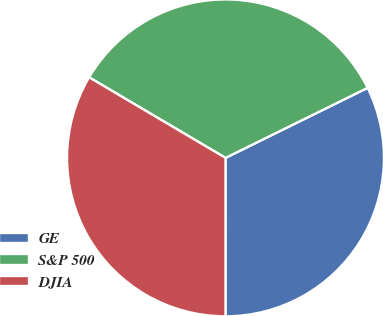<chart> <loc_0><loc_0><loc_500><loc_500><pie_chart><fcel>GE<fcel>S&P 500<fcel>DJIA<nl><fcel>32.29%<fcel>34.22%<fcel>33.49%<nl></chart> 